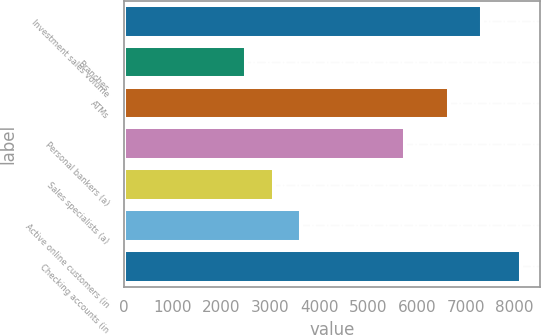Convert chart to OTSL. <chart><loc_0><loc_0><loc_500><loc_500><bar_chart><fcel>Investment sales volume<fcel>Branches<fcel>ATMs<fcel>Personal bankers (a)<fcel>Sales specialists (a)<fcel>Active online customers (in<fcel>Checking accounts (in<nl><fcel>7324<fcel>2508<fcel>6650<fcel>5750<fcel>3069.6<fcel>3631.2<fcel>8124<nl></chart> 